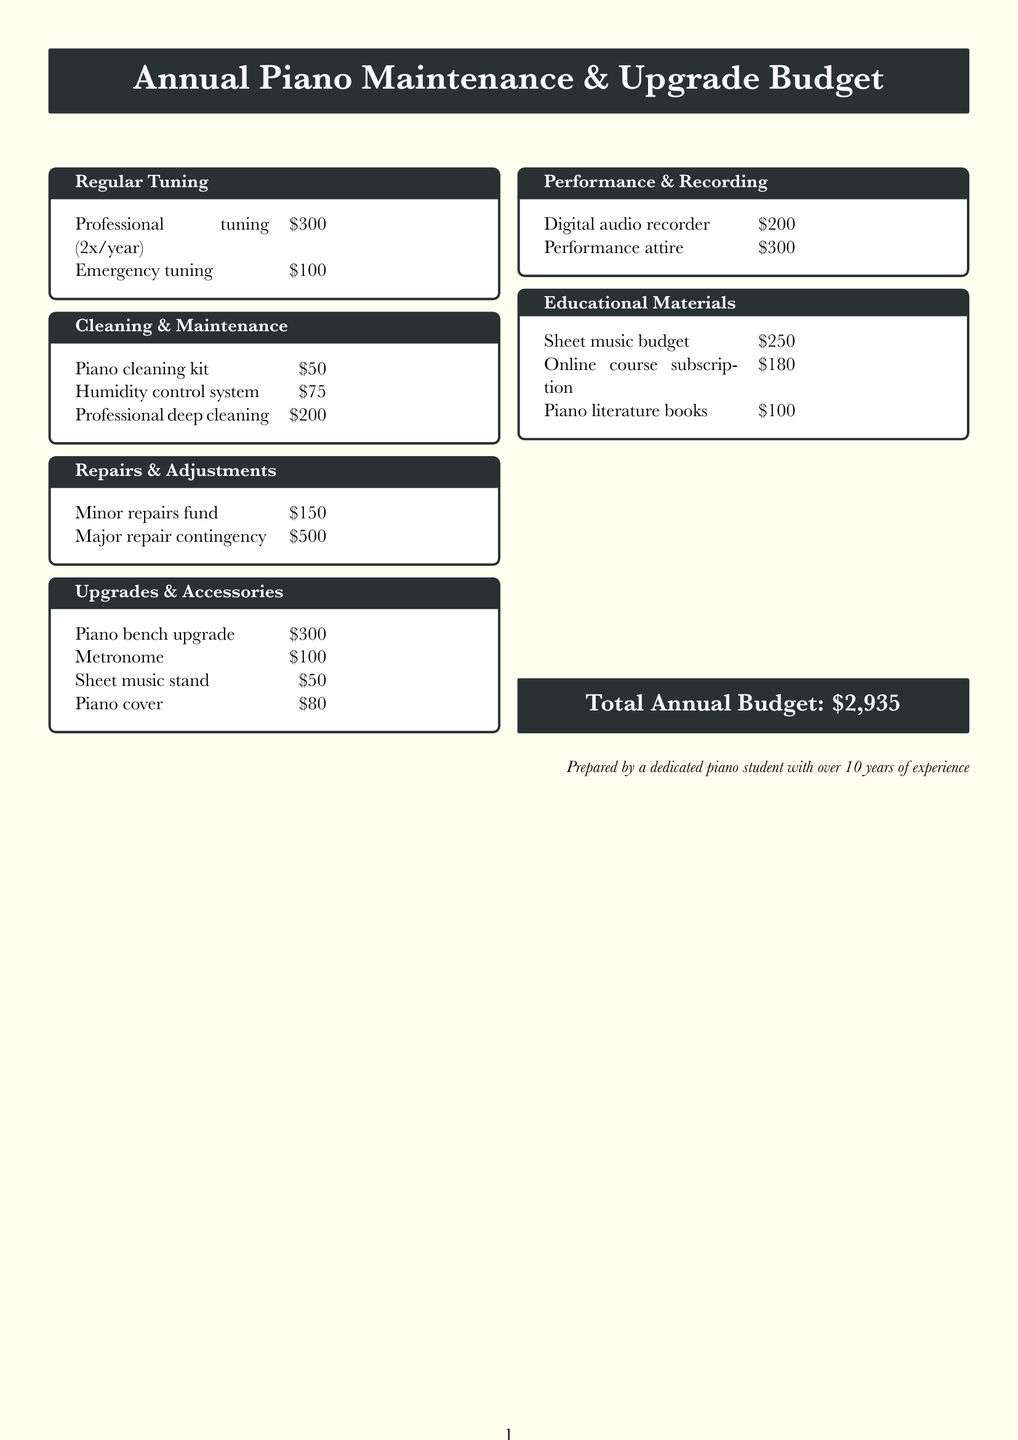What is the total annual budget? The total annual budget is stated at the bottom of the document, which amounts to $2,935.
Answer: $2,935 How many times a year is professional tuning done? The document specifies that professional tuning is performed twice a year.
Answer: twice a year What is the cost of the humidity control system? The cost of the humidity control system is listed in the cleaning and maintenance section.
Answer: $75 What fund is allocated for minor repairs? The document mentions a specific fund set aside for minor repairs.
Answer: Minor repairs fund What is included in the piano cleaning kit? The description of the piano cleaning kit indicates specific items included for maintenance.
Answer: Cory key-brite, polish, and cleaning cloth What kind of digital audio recorder is in the budget? The document specifies the model of the digital audio recorder listed under performance and recording.
Answer: Zoom H4n Pro Which category includes the piano bench upgrade? The document includes various categories, and the piano bench upgrade is situated in one of them.
Answer: Upgrades and Accessories How much is allocated for online course subscription? The document provides a specific amount for the online course subscription related to education.
Answer: $180 What type of performance attire does the budget include? The document mentions a specific category for items related to performance attire.
Answer: Formal wear for recitals and concerts 